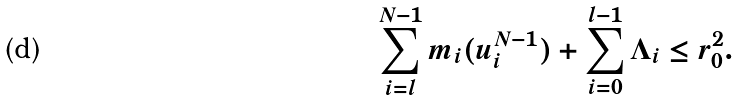Convert formula to latex. <formula><loc_0><loc_0><loc_500><loc_500>\sum _ { i = l } ^ { N - 1 } m _ { i } ( u _ { i } ^ { N - 1 } ) + \sum _ { i = 0 } ^ { l - 1 } \Lambda _ { i } \leq r _ { 0 } ^ { 2 } .</formula> 